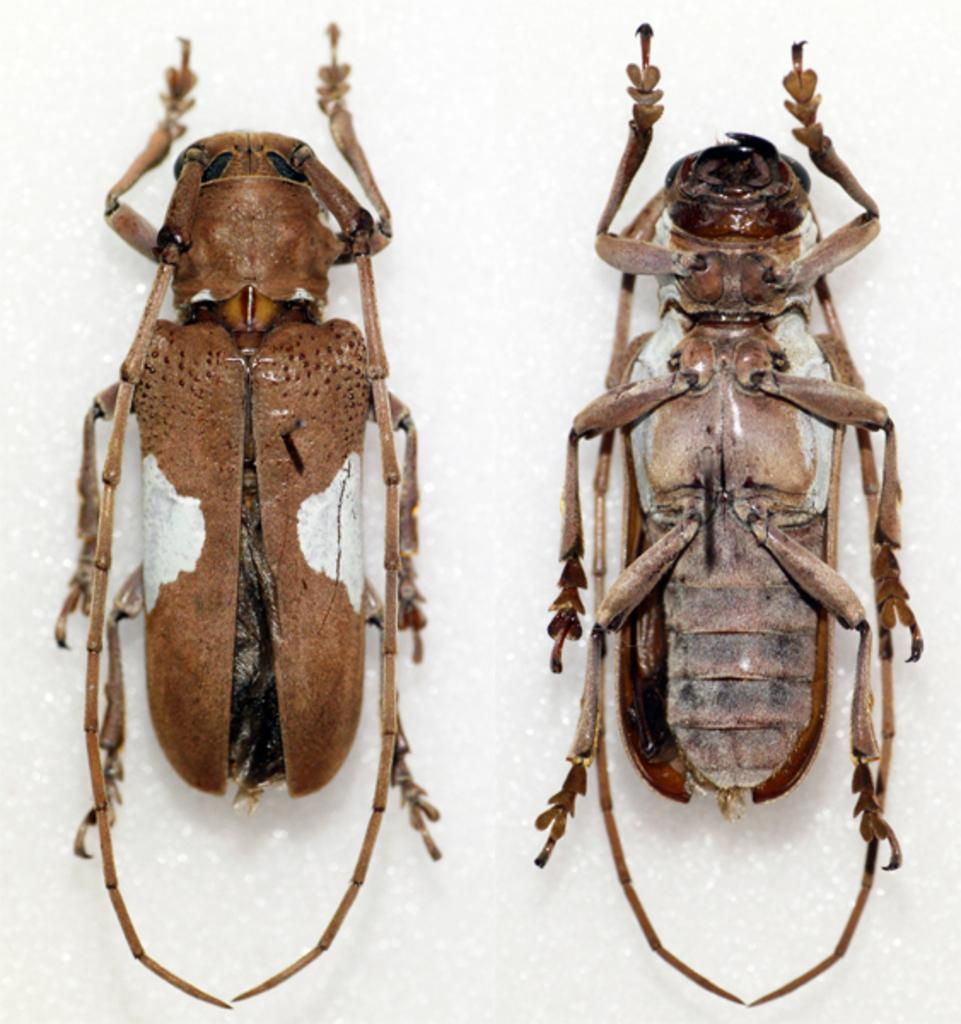What type of creatures can be seen in the image? There are two insects in the image. Where are the insects located in the image? The insects are in the middle of the image. What type of drug is the insect carrying on the sidewalk in the image? There is no drug or sidewalk present in the image, and the insects are not carrying anything. 